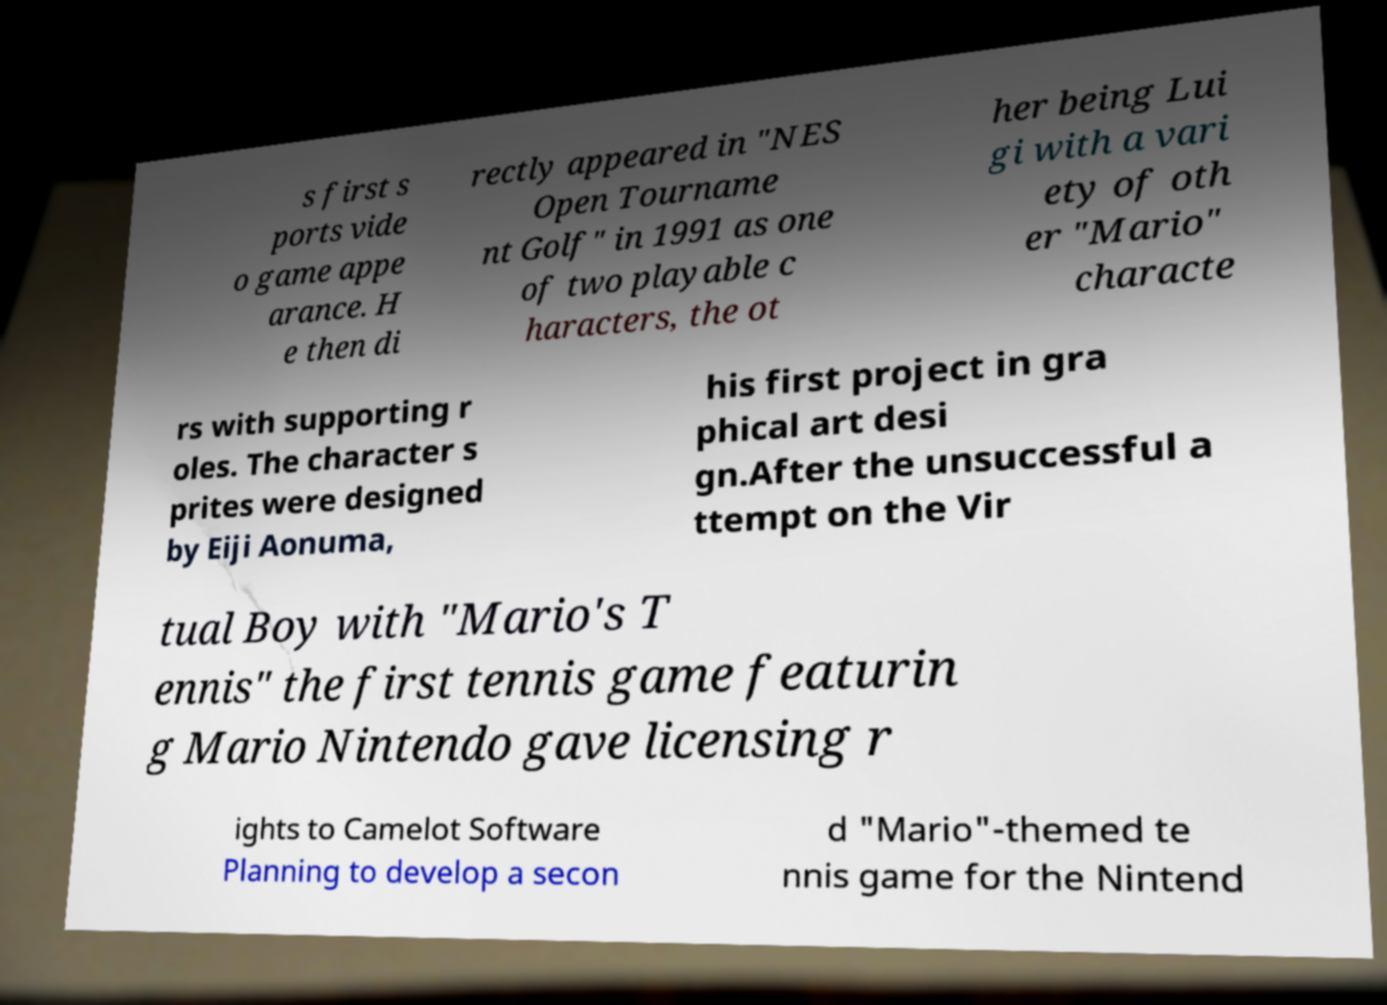Can you read and provide the text displayed in the image?This photo seems to have some interesting text. Can you extract and type it out for me? s first s ports vide o game appe arance. H e then di rectly appeared in "NES Open Tourname nt Golf" in 1991 as one of two playable c haracters, the ot her being Lui gi with a vari ety of oth er "Mario" characte rs with supporting r oles. The character s prites were designed by Eiji Aonuma, his first project in gra phical art desi gn.After the unsuccessful a ttempt on the Vir tual Boy with "Mario's T ennis" the first tennis game featurin g Mario Nintendo gave licensing r ights to Camelot Software Planning to develop a secon d "Mario"-themed te nnis game for the Nintend 